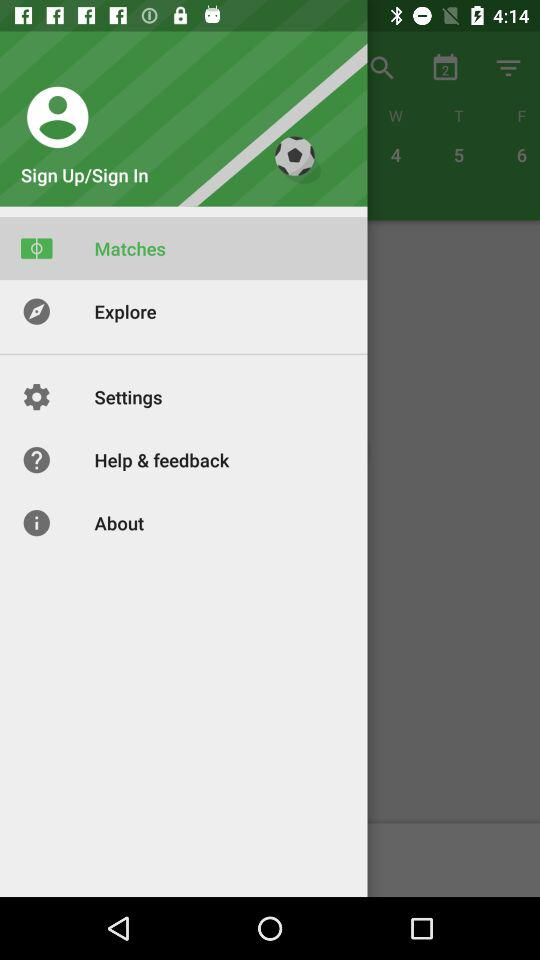Which item is selected? The selected item is "Matches". 